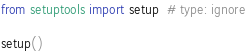Convert code to text. <code><loc_0><loc_0><loc_500><loc_500><_Python_>from setuptools import setup  # type: ignore

setup()</code> 